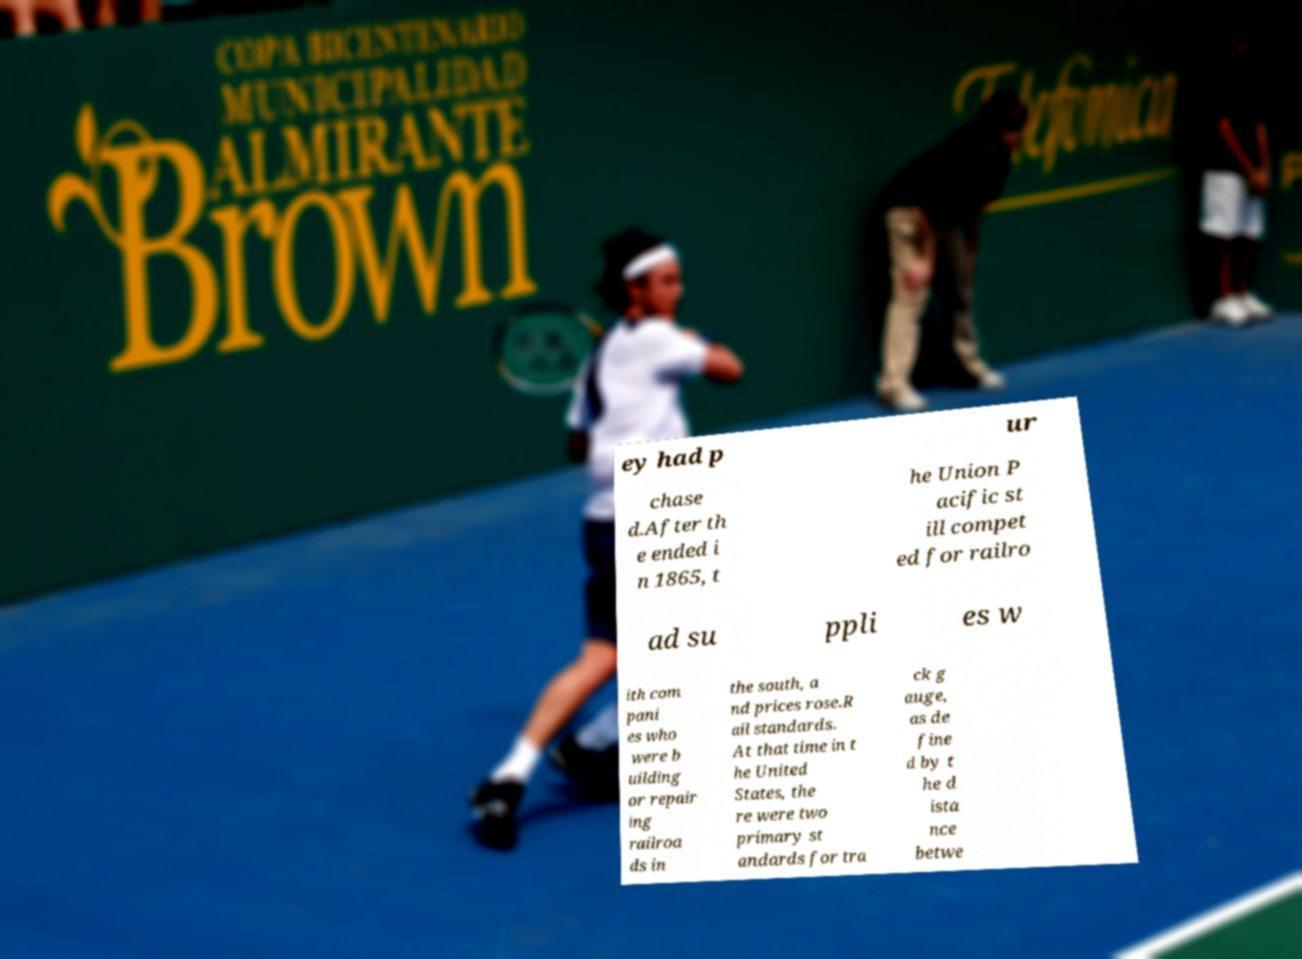There's text embedded in this image that I need extracted. Can you transcribe it verbatim? ey had p ur chase d.After th e ended i n 1865, t he Union P acific st ill compet ed for railro ad su ppli es w ith com pani es who were b uilding or repair ing railroa ds in the south, a nd prices rose.R ail standards. At that time in t he United States, the re were two primary st andards for tra ck g auge, as de fine d by t he d ista nce betwe 